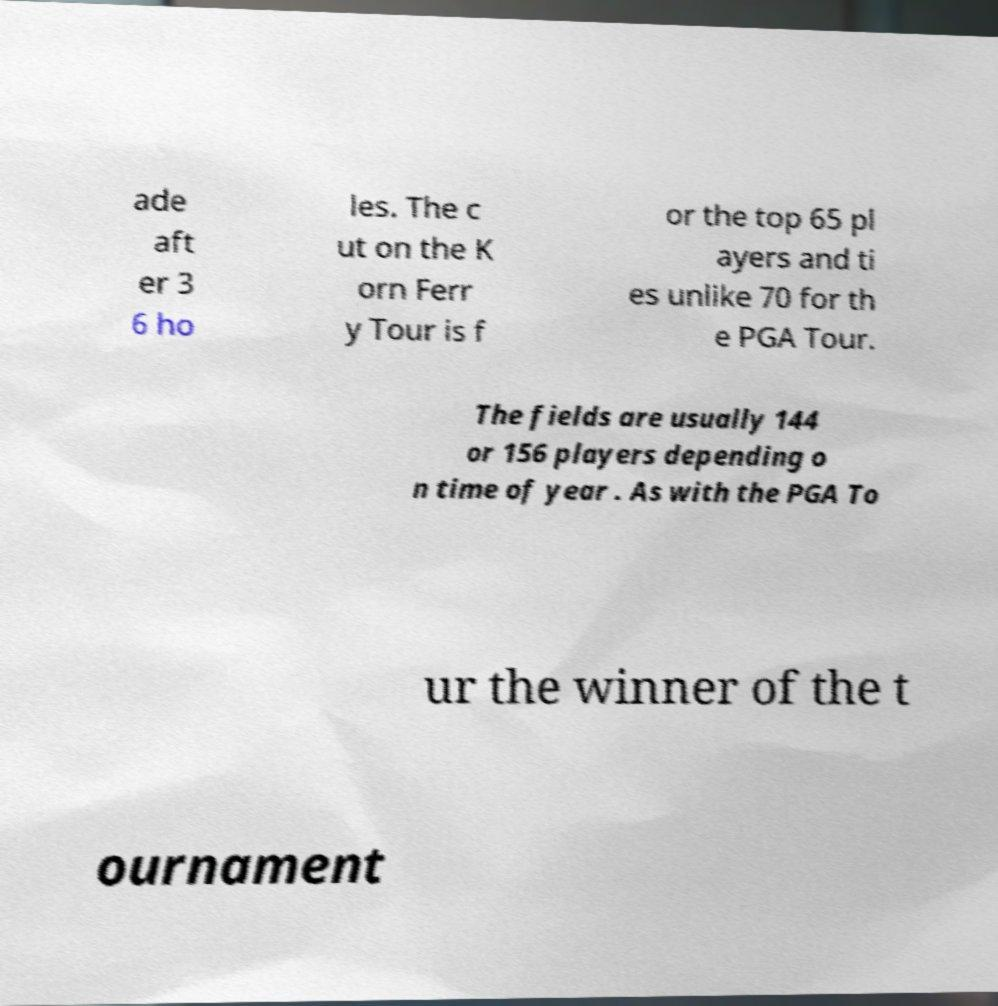Can you accurately transcribe the text from the provided image for me? ade aft er 3 6 ho les. The c ut on the K orn Ferr y Tour is f or the top 65 pl ayers and ti es unlike 70 for th e PGA Tour. The fields are usually 144 or 156 players depending o n time of year . As with the PGA To ur the winner of the t ournament 